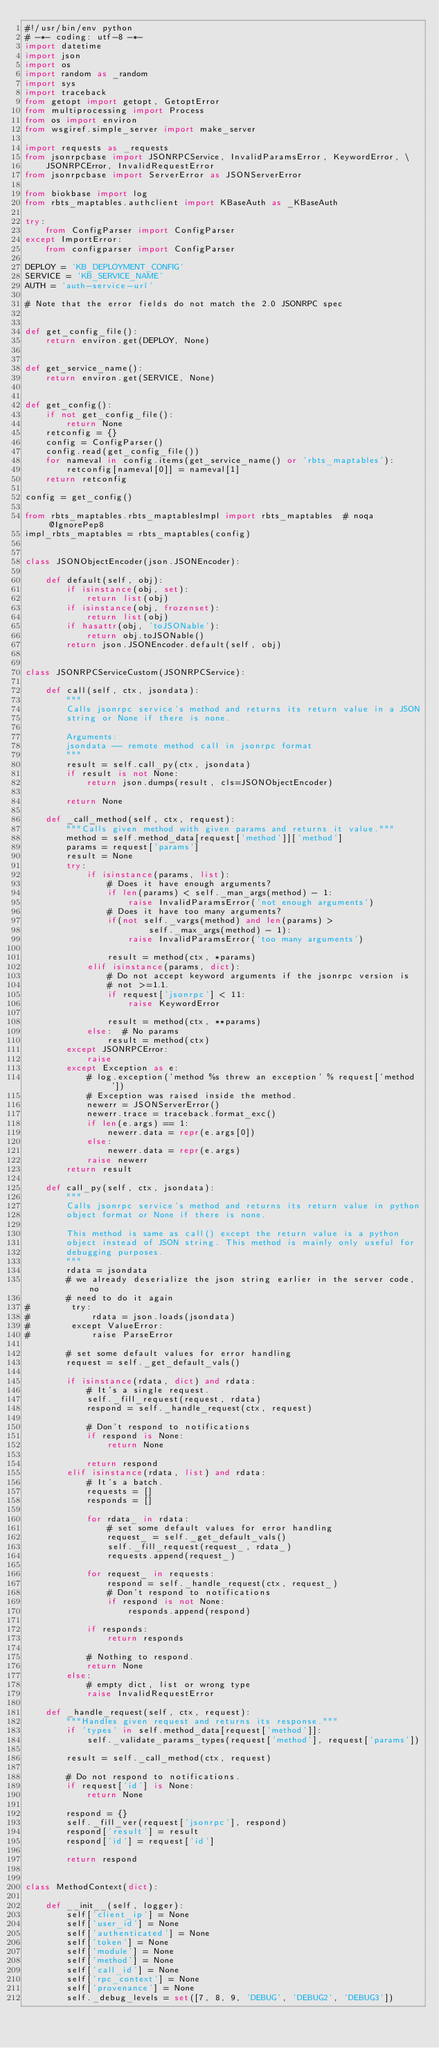<code> <loc_0><loc_0><loc_500><loc_500><_Python_>#!/usr/bin/env python
# -*- coding: utf-8 -*-
import datetime
import json
import os
import random as _random
import sys
import traceback
from getopt import getopt, GetoptError
from multiprocessing import Process
from os import environ
from wsgiref.simple_server import make_server

import requests as _requests
from jsonrpcbase import JSONRPCService, InvalidParamsError, KeywordError, \
    JSONRPCError, InvalidRequestError
from jsonrpcbase import ServerError as JSONServerError

from biokbase import log
from rbts_maptables.authclient import KBaseAuth as _KBaseAuth

try:
    from ConfigParser import ConfigParser
except ImportError:
    from configparser import ConfigParser

DEPLOY = 'KB_DEPLOYMENT_CONFIG'
SERVICE = 'KB_SERVICE_NAME'
AUTH = 'auth-service-url'

# Note that the error fields do not match the 2.0 JSONRPC spec


def get_config_file():
    return environ.get(DEPLOY, None)


def get_service_name():
    return environ.get(SERVICE, None)


def get_config():
    if not get_config_file():
        return None
    retconfig = {}
    config = ConfigParser()
    config.read(get_config_file())
    for nameval in config.items(get_service_name() or 'rbts_maptables'):
        retconfig[nameval[0]] = nameval[1]
    return retconfig

config = get_config()

from rbts_maptables.rbts_maptablesImpl import rbts_maptables  # noqa @IgnorePep8
impl_rbts_maptables = rbts_maptables(config)


class JSONObjectEncoder(json.JSONEncoder):

    def default(self, obj):
        if isinstance(obj, set):
            return list(obj)
        if isinstance(obj, frozenset):
            return list(obj)
        if hasattr(obj, 'toJSONable'):
            return obj.toJSONable()
        return json.JSONEncoder.default(self, obj)


class JSONRPCServiceCustom(JSONRPCService):

    def call(self, ctx, jsondata):
        """
        Calls jsonrpc service's method and returns its return value in a JSON
        string or None if there is none.

        Arguments:
        jsondata -- remote method call in jsonrpc format
        """
        result = self.call_py(ctx, jsondata)
        if result is not None:
            return json.dumps(result, cls=JSONObjectEncoder)

        return None

    def _call_method(self, ctx, request):
        """Calls given method with given params and returns it value."""
        method = self.method_data[request['method']]['method']
        params = request['params']
        result = None
        try:
            if isinstance(params, list):
                # Does it have enough arguments?
                if len(params) < self._man_args(method) - 1:
                    raise InvalidParamsError('not enough arguments')
                # Does it have too many arguments?
                if(not self._vargs(method) and len(params) >
                        self._max_args(method) - 1):
                    raise InvalidParamsError('too many arguments')

                result = method(ctx, *params)
            elif isinstance(params, dict):
                # Do not accept keyword arguments if the jsonrpc version is
                # not >=1.1.
                if request['jsonrpc'] < 11:
                    raise KeywordError

                result = method(ctx, **params)
            else:  # No params
                result = method(ctx)
        except JSONRPCError:
            raise
        except Exception as e:
            # log.exception('method %s threw an exception' % request['method'])
            # Exception was raised inside the method.
            newerr = JSONServerError()
            newerr.trace = traceback.format_exc()
            if len(e.args) == 1:
                newerr.data = repr(e.args[0])
            else:
                newerr.data = repr(e.args)
            raise newerr
        return result

    def call_py(self, ctx, jsondata):
        """
        Calls jsonrpc service's method and returns its return value in python
        object format or None if there is none.

        This method is same as call() except the return value is a python
        object instead of JSON string. This method is mainly only useful for
        debugging purposes.
        """
        rdata = jsondata
        # we already deserialize the json string earlier in the server code, no
        # need to do it again
#        try:
#            rdata = json.loads(jsondata)
#        except ValueError:
#            raise ParseError

        # set some default values for error handling
        request = self._get_default_vals()

        if isinstance(rdata, dict) and rdata:
            # It's a single request.
            self._fill_request(request, rdata)
            respond = self._handle_request(ctx, request)

            # Don't respond to notifications
            if respond is None:
                return None

            return respond
        elif isinstance(rdata, list) and rdata:
            # It's a batch.
            requests = []
            responds = []

            for rdata_ in rdata:
                # set some default values for error handling
                request_ = self._get_default_vals()
                self._fill_request(request_, rdata_)
                requests.append(request_)

            for request_ in requests:
                respond = self._handle_request(ctx, request_)
                # Don't respond to notifications
                if respond is not None:
                    responds.append(respond)

            if responds:
                return responds

            # Nothing to respond.
            return None
        else:
            # empty dict, list or wrong type
            raise InvalidRequestError

    def _handle_request(self, ctx, request):
        """Handles given request and returns its response."""
        if 'types' in self.method_data[request['method']]:
            self._validate_params_types(request['method'], request['params'])

        result = self._call_method(ctx, request)

        # Do not respond to notifications.
        if request['id'] is None:
            return None

        respond = {}
        self._fill_ver(request['jsonrpc'], respond)
        respond['result'] = result
        respond['id'] = request['id']

        return respond


class MethodContext(dict):

    def __init__(self, logger):
        self['client_ip'] = None
        self['user_id'] = None
        self['authenticated'] = None
        self['token'] = None
        self['module'] = None
        self['method'] = None
        self['call_id'] = None
        self['rpc_context'] = None
        self['provenance'] = None
        self._debug_levels = set([7, 8, 9, 'DEBUG', 'DEBUG2', 'DEBUG3'])</code> 